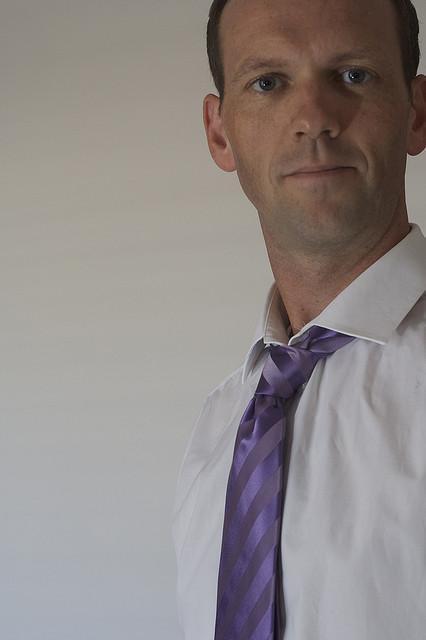How many airplanes do you see?
Give a very brief answer. 0. 